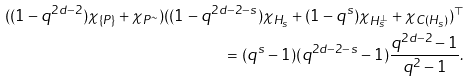Convert formula to latex. <formula><loc_0><loc_0><loc_500><loc_500>( ( 1 - q ^ { 2 d - 2 } ) \chi _ { \{ P \} } + \chi _ { P ^ { \sim } } ) ( ( 1 - q ^ { 2 d - 2 - s } ) \chi _ { H _ { s } } + ( 1 - q ^ { s } ) \chi _ { H _ { s } ^ { \perp } } + \chi _ { C ( H _ { s } ) } ) ^ { \top } \\ = ( q ^ { s } - 1 ) ( q ^ { 2 d - 2 - s } - 1 ) \frac { q ^ { 2 d - 2 } - 1 } { q ^ { 2 } - 1 } .</formula> 